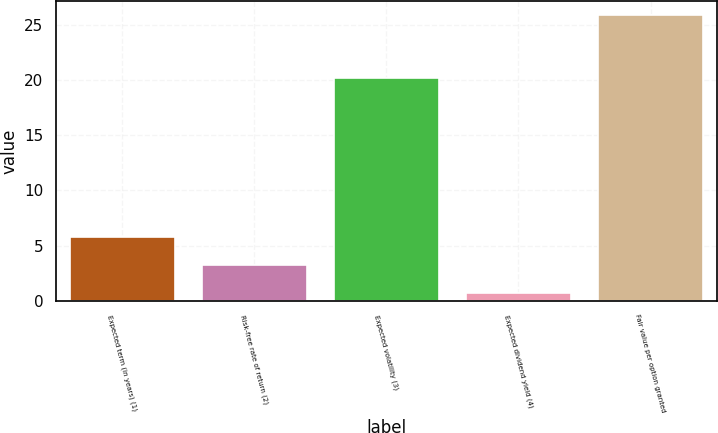Convert chart to OTSL. <chart><loc_0><loc_0><loc_500><loc_500><bar_chart><fcel>Expected term (in years) (1)<fcel>Risk-free rate of return (2)<fcel>Expected volatility (3)<fcel>Expected dividend yield (4)<fcel>Fair value per option granted<nl><fcel>5.74<fcel>3.22<fcel>20.2<fcel>0.7<fcel>25.89<nl></chart> 